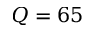Convert formula to latex. <formula><loc_0><loc_0><loc_500><loc_500>Q = 6 5</formula> 